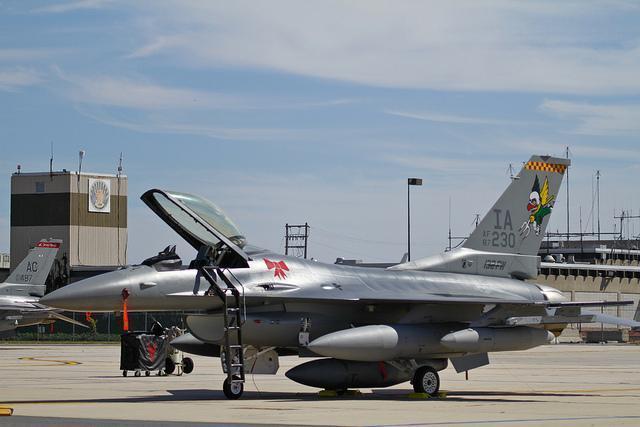How many airplanes are there?
Give a very brief answer. 2. How many mice are in this scene?
Give a very brief answer. 0. 